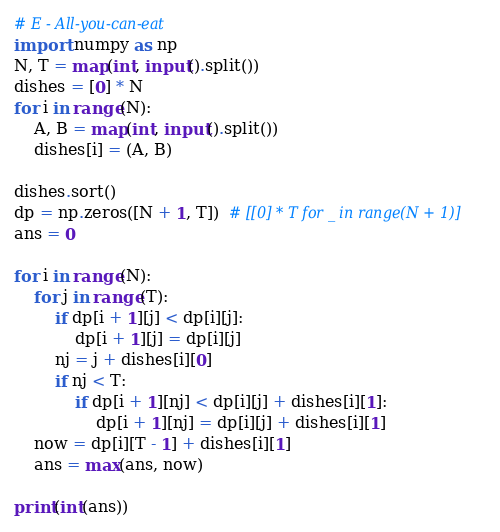<code> <loc_0><loc_0><loc_500><loc_500><_Python_># E - All-you-can-eat
import numpy as np
N, T = map(int, input().split())
dishes = [0] * N
for i in range(N):
    A, B = map(int, input().split())
    dishes[i] = (A, B)

dishes.sort()
dp = np.zeros([N + 1, T])  # [[0] * T for _ in range(N + 1)]
ans = 0

for i in range(N):
    for j in range(T):
        if dp[i + 1][j] < dp[i][j]:
            dp[i + 1][j] = dp[i][j]
        nj = j + dishes[i][0]
        if nj < T:
            if dp[i + 1][nj] < dp[i][j] + dishes[i][1]:
                dp[i + 1][nj] = dp[i][j] + dishes[i][1]
    now = dp[i][T - 1] + dishes[i][1]
    ans = max(ans, now)
    
print(int(ans))</code> 